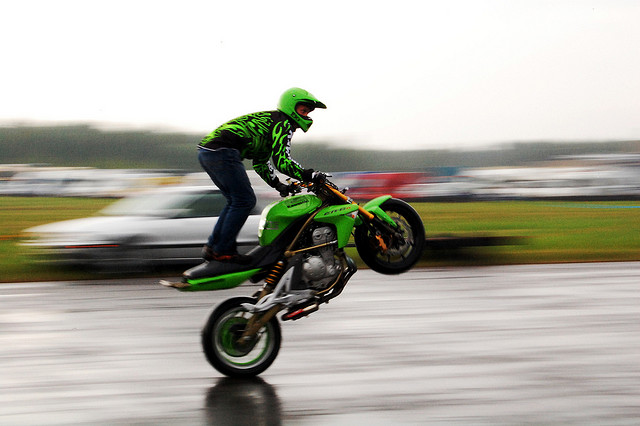Are there any obvious noise spots?
A. Yes, there are obvious noise spots.
B. The image has a few noise spots.
C. No, there are no obvious noise spots.
Answer with the option's letter from the given choices directly.
 C. 